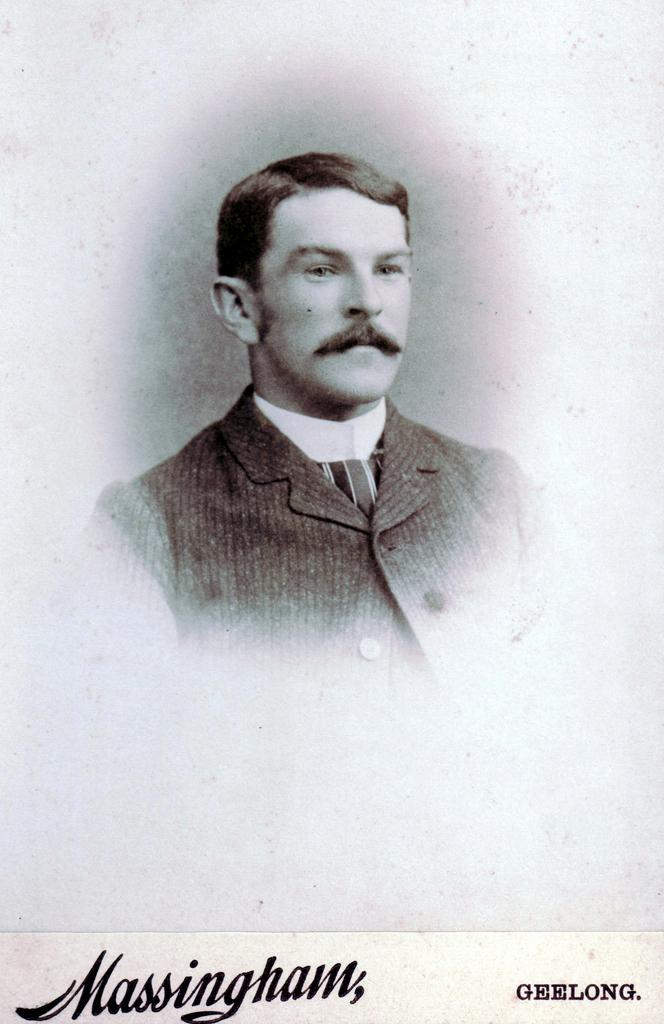What is the main subject of the image? The main subject of the image is a man. Are there any other elements present in the image besides the man? Yes, there are letters on the image. What type of view can be seen in the image? There is no specific view mentioned in the facts provided; the image only contains a man and letters. How many women are present in the image? There is no mention of any women in the image. What type of iron object can be seen in the image? There is no iron object present in the image. 